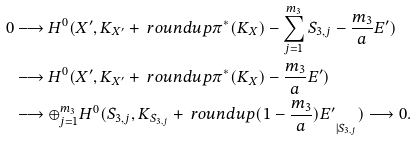Convert formula to latex. <formula><loc_0><loc_0><loc_500><loc_500>0 & \longrightarrow H ^ { 0 } ( X ^ { \prime } , K _ { X ^ { \prime } } + \ r o u n d u p { \pi ^ { * } ( K _ { X } ) - \sum _ { j = 1 } ^ { m _ { 3 } } S _ { 3 , j } - \frac { m _ { 3 } } { a } E ^ { \prime } } ) \\ & \longrightarrow H ^ { 0 } ( X ^ { \prime } , K _ { X ^ { \prime } } + \ r o u n d u p { \pi ^ { * } ( K _ { X } ) - \frac { m _ { 3 } } { a } E ^ { \prime } } ) \\ & \longrightarrow \oplus _ { j = 1 } ^ { m _ { 3 } } H ^ { 0 } ( S _ { 3 , j } , K _ { S _ { 3 , j } } + \ r o u n d u p { ( 1 - \frac { m _ { 3 } } { a } ) E ^ { \prime } } _ { | { S _ { 3 , j } } } ) \longrightarrow 0 .</formula> 